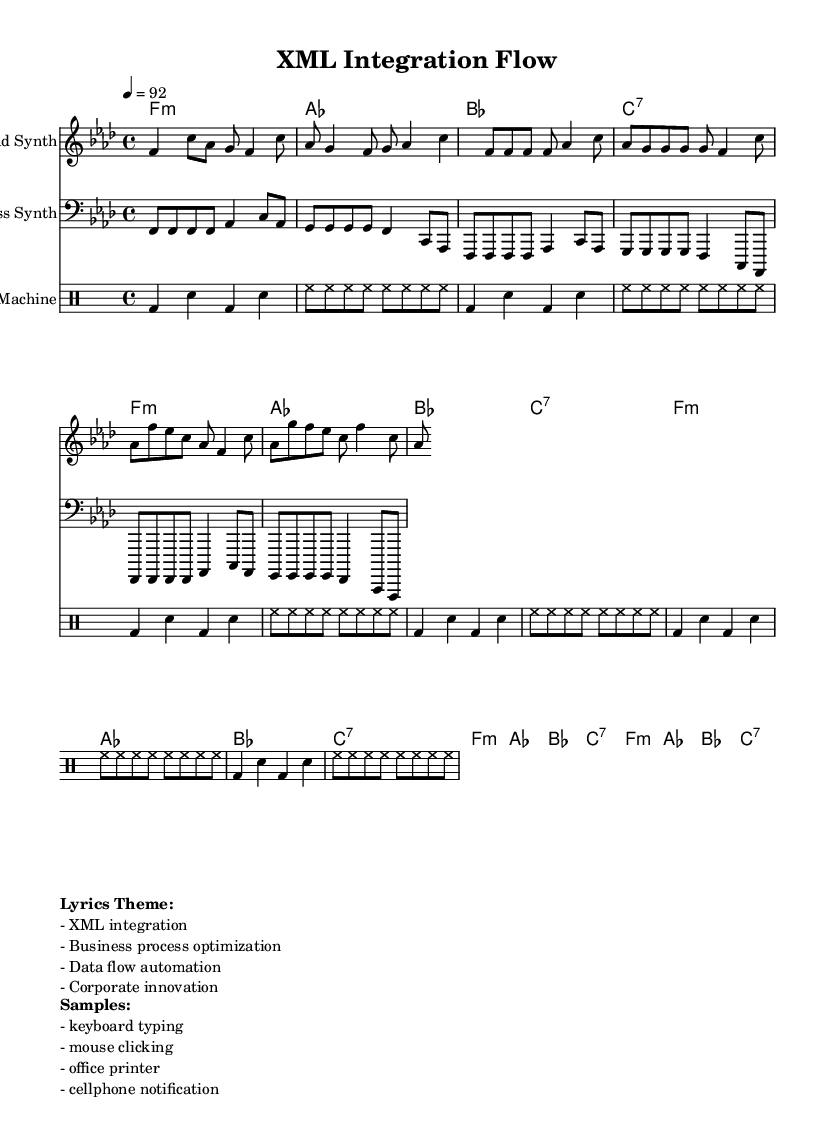What is the key signature of this music? The key signature indicates F minor, which has four flats (B♭, E♭, A♭, and D♭). This is derived from the global setup in the code that specifies `\key f \minor`.
Answer: F minor What is the time signature of this music? The time signature is 4/4, as indicated by `\time 4/4` in the global setup. This means there are four beats in each measure, and a quarter note gets one beat.
Answer: 4/4 What is the tempo marking in this piece? The tempo is marked at 92 beats per minute, specified by `\tempo 4 = 92`. This indicates the speed at which the music should be played.
Answer: 92 How many measures are in the verse section? The verse section consists of three measures, calculated from the lead synth section where the verse is defined. The notes group into measures, and counting these results in three distinct groups.
Answer: 3 What type of instrument is used for the bass line? The bass line is played by a bass synth, which is clearly labeled in the staff description as `Bass Synth` in the score setup.
Answer: Bass Synth What themes are discussed in the lyrics of this hip hop piece? The themes include XML integration, business process optimization, data flow automation, and corporate innovation, as indicated in the marked section titled "Lyrics Theme" of the markup.
Answer: XML integration, business process optimization, data flow automation, corporate innovation How is the drum pattern structured in this piece? The drum pattern is structured with a repeating sequence of bass drum and snare, along with hi-hat notes. This is specified in the `\drummode` section where the patterns repeat. The unfolding repetition of `bd` (bass drum) and `sn` (snare) gives us the structure.
Answer: Repeating bass drum and snare pattern 